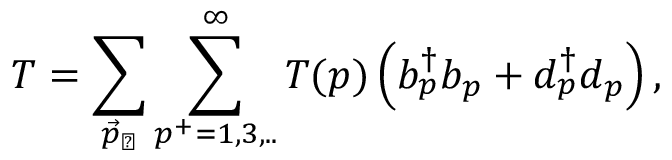<formula> <loc_0><loc_0><loc_500><loc_500>T = \sum _ { { \vec { p } } _ { \perp } } \sum _ { p ^ { + } = 1 , 3 , . . } ^ { \infty } T ( p ) \left ( b _ { p } ^ { \dagger } b _ { p } + d _ { p } ^ { \dagger } d _ { p } \right ) ,</formula> 